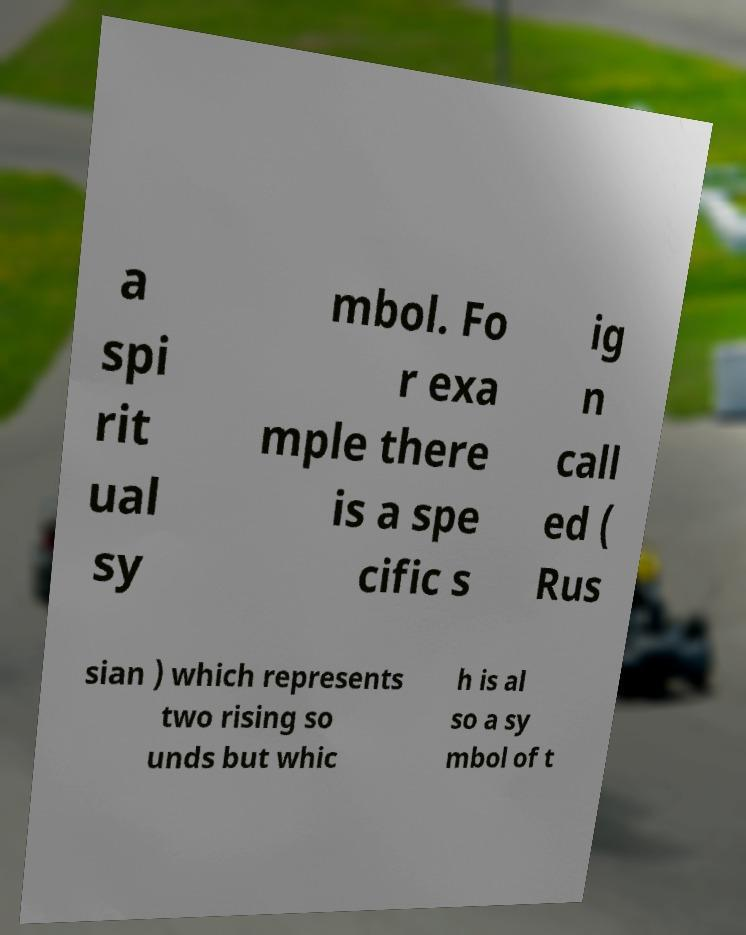For documentation purposes, I need the text within this image transcribed. Could you provide that? a spi rit ual sy mbol. Fo r exa mple there is a spe cific s ig n call ed ( Rus sian ) which represents two rising so unds but whic h is al so a sy mbol of t 